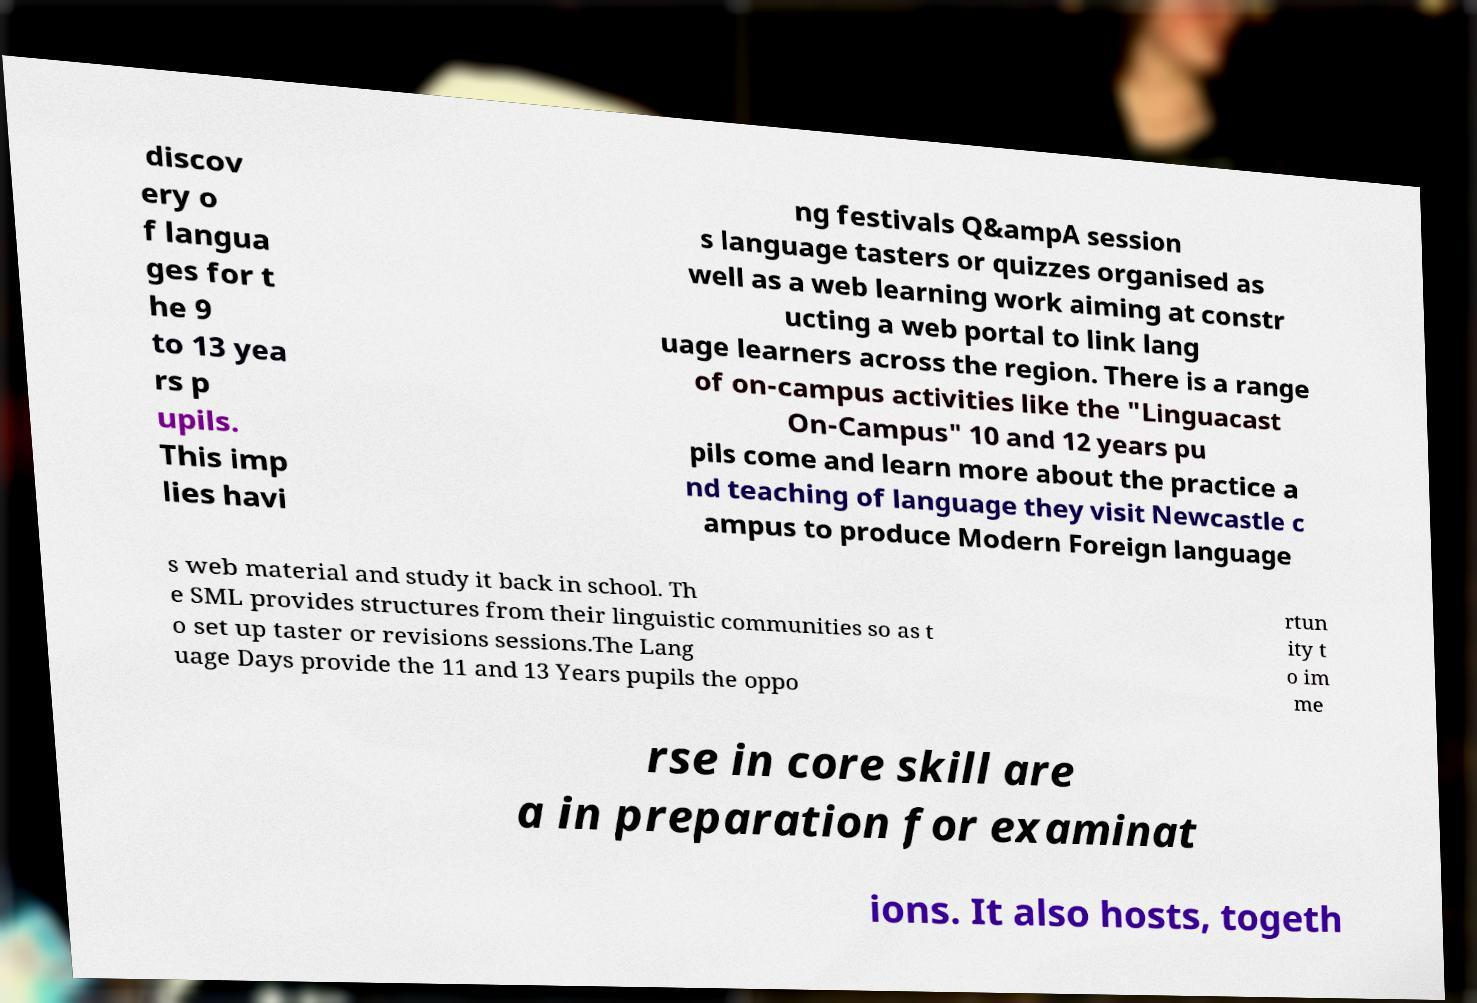Can you read and provide the text displayed in the image?This photo seems to have some interesting text. Can you extract and type it out for me? discov ery o f langua ges for t he 9 to 13 yea rs p upils. This imp lies havi ng festivals Q&ampA session s language tasters or quizzes organised as well as a web learning work aiming at constr ucting a web portal to link lang uage learners across the region. There is a range of on-campus activities like the "Linguacast On-Campus" 10 and 12 years pu pils come and learn more about the practice a nd teaching of language they visit Newcastle c ampus to produce Modern Foreign language s web material and study it back in school. Th e SML provides structures from their linguistic communities so as t o set up taster or revisions sessions.The Lang uage Days provide the 11 and 13 Years pupils the oppo rtun ity t o im me rse in core skill are a in preparation for examinat ions. It also hosts, togeth 